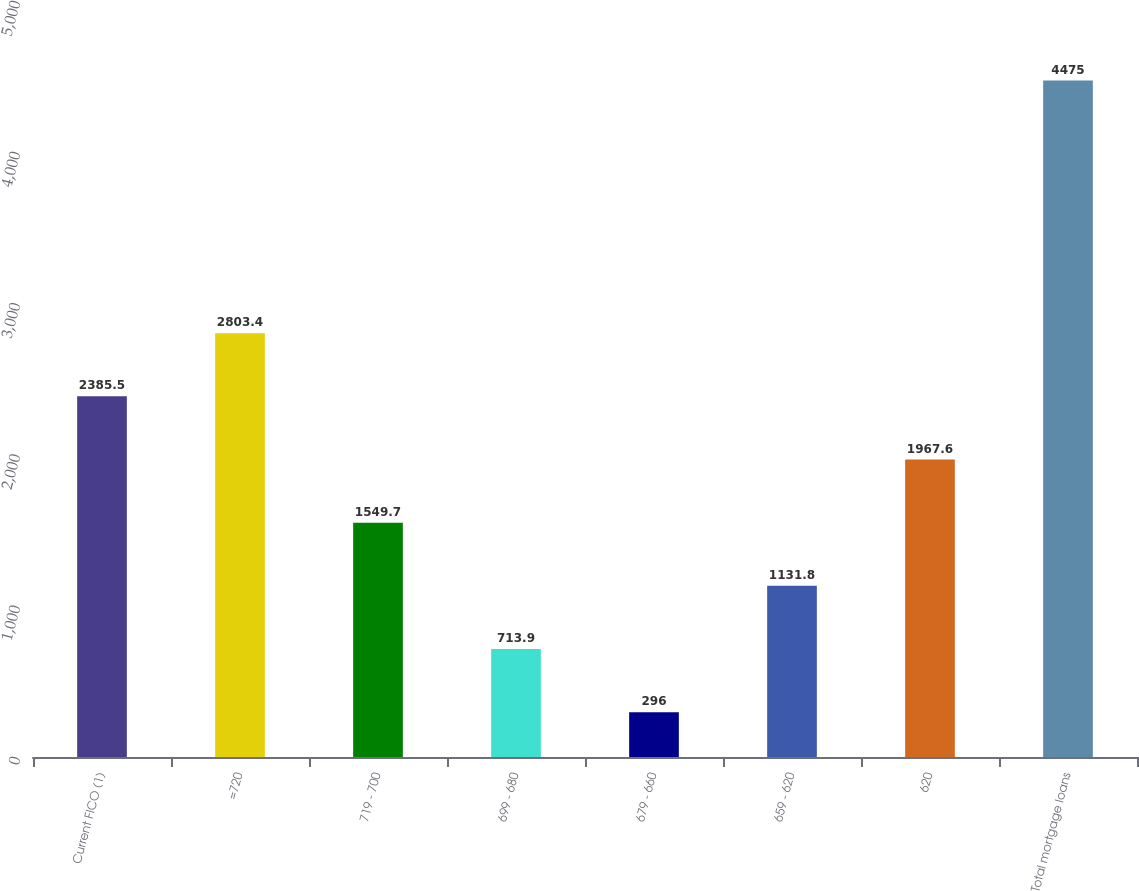Convert chart to OTSL. <chart><loc_0><loc_0><loc_500><loc_500><bar_chart><fcel>Current FICO (1)<fcel>=720<fcel>719 - 700<fcel>699 - 680<fcel>679 - 660<fcel>659 - 620<fcel>620<fcel>Total mortgage loans<nl><fcel>2385.5<fcel>2803.4<fcel>1549.7<fcel>713.9<fcel>296<fcel>1131.8<fcel>1967.6<fcel>4475<nl></chart> 